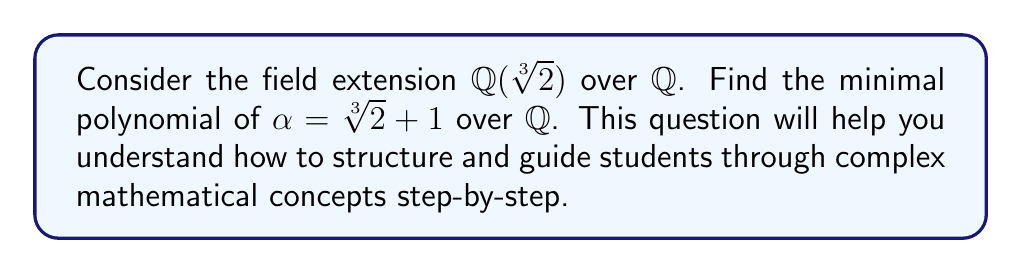Give your solution to this math problem. Let's approach this problem systematically:

1) First, we know that $\sqrt[3]{2}$ is a root of $x^3 - 2 = 0$. Let $\beta = \sqrt[3]{2}$.

2) We want to find a polynomial with rational coefficients that has $\alpha = \beta + 1$ as a root.

3) Let's substitute $\alpha - 1$ for $\beta$ in the equation $\beta^3 - 2 = 0$:

   $(\alpha - 1)^3 - 2 = 0$

4) Expand this equation:
   
   $\alpha^3 - 3\alpha^2 + 3\alpha - 1 - 2 = 0$
   $\alpha^3 - 3\alpha^2 + 3\alpha - 3 = 0$

5) This polynomial has rational coefficients and $\alpha$ as a root. However, we need to verify if it's the minimal polynomial.

6) The degree of this polynomial is 3, which is equal to the degree of the extension $[\mathbb{Q}(\sqrt[3]{2}):\mathbb{Q}]$. 

7) Since the degree of the minimal polynomial of $\alpha$ over $\mathbb{Q}$ cannot exceed the degree of the extension, and we have found a polynomial of degree 3 with $\alpha$ as a root, this must be the minimal polynomial.

Therefore, the minimal polynomial of $\alpha = \sqrt[3]{2} + 1$ over $\mathbb{Q}$ is $x^3 - 3x^2 + 3x - 3$.
Answer: $x^3 - 3x^2 + 3x - 3$ 